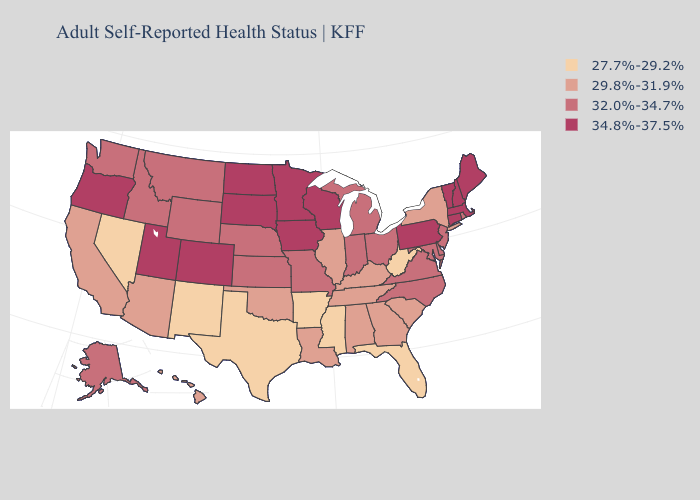Which states have the lowest value in the USA?
Short answer required. Arkansas, Florida, Mississippi, Nevada, New Mexico, Texas, West Virginia. Does West Virginia have a lower value than Texas?
Concise answer only. No. What is the lowest value in states that border Colorado?
Give a very brief answer. 27.7%-29.2%. What is the lowest value in states that border Florida?
Give a very brief answer. 29.8%-31.9%. Name the states that have a value in the range 29.8%-31.9%?
Give a very brief answer. Alabama, Arizona, California, Georgia, Hawaii, Illinois, Kentucky, Louisiana, New York, Oklahoma, South Carolina, Tennessee. What is the highest value in the South ?
Give a very brief answer. 32.0%-34.7%. Among the states that border Georgia , does North Carolina have the lowest value?
Quick response, please. No. Name the states that have a value in the range 27.7%-29.2%?
Quick response, please. Arkansas, Florida, Mississippi, Nevada, New Mexico, Texas, West Virginia. What is the highest value in the Northeast ?
Keep it brief. 34.8%-37.5%. Name the states that have a value in the range 27.7%-29.2%?
Write a very short answer. Arkansas, Florida, Mississippi, Nevada, New Mexico, Texas, West Virginia. What is the value of New York?
Give a very brief answer. 29.8%-31.9%. Does California have the lowest value in the USA?
Give a very brief answer. No. Name the states that have a value in the range 34.8%-37.5%?
Concise answer only. Colorado, Connecticut, Iowa, Maine, Massachusetts, Minnesota, New Hampshire, North Dakota, Oregon, Pennsylvania, South Dakota, Utah, Vermont, Wisconsin. Which states have the highest value in the USA?
Quick response, please. Colorado, Connecticut, Iowa, Maine, Massachusetts, Minnesota, New Hampshire, North Dakota, Oregon, Pennsylvania, South Dakota, Utah, Vermont, Wisconsin. Does the map have missing data?
Be succinct. No. 